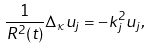<formula> <loc_0><loc_0><loc_500><loc_500>\frac { 1 } { R ^ { 2 } ( t ) } \Delta _ { \kappa } u _ { j } = - k _ { j } ^ { 2 } u _ { j } ,</formula> 